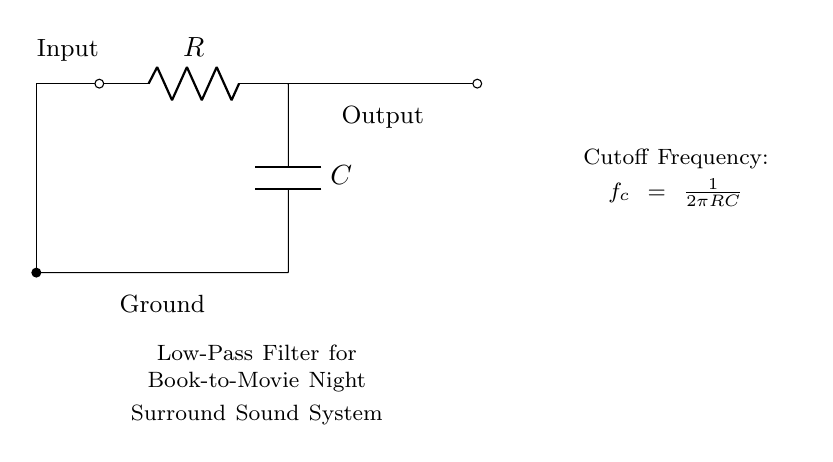What is the type of filter shown in the circuit? The circuit shows a low-pass filter, which allows signals below a certain cutoff frequency to pass while attenuating signals above that frequency.
Answer: low-pass filter What does the letter "R" represent in the circuit? In the diagram, "R" represents a resistor, which is a component that limits the flow of electric current.
Answer: resistor What does the letter "C" represent in the circuit? "C" in this circuit diagram represents a capacitor, which stores electric energy temporarily in an electric field.
Answer: capacitor What is the cutoff frequency formula in the circuit? The cutoff frequency is given by the formula f_c = 1/(2πRC), where R is the resistance and C is the capacitance. This indicates how these components interact to define the frequency at which the filter operates.
Answer: f_c = 1/(2πRC) What is the output point of the circuit indicated by? The output point is indicated by the terminal noted as "Output," which is where the filtered signal can be taken from the circuit.
Answer: Output Which component determines the frequency response of this filter? The combination of the resistor "R" and the capacitor "C" together determines the frequency response of the low-pass filter, influencing which frequencies are allowed to pass through.
Answer: R and C Why is this filter useful for a surround sound system? A low-pass filter is useful in a surround sound system as it allows lower frequency sounds, such as bass, to be amplified while filtering out higher frequencies, ensuring a rich audio experience for movie nights.
Answer: audio enhancement 